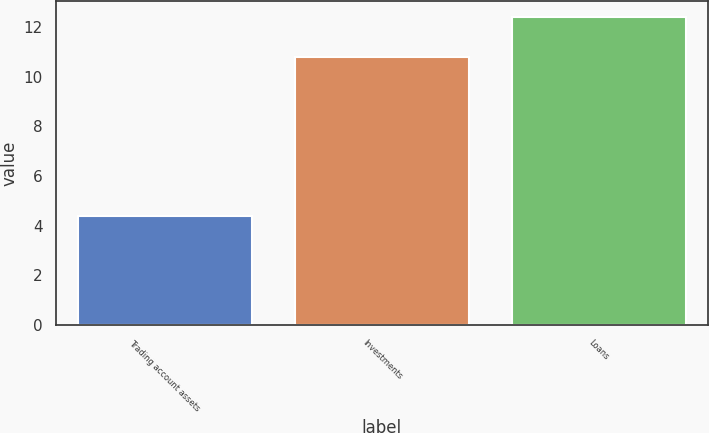Convert chart to OTSL. <chart><loc_0><loc_0><loc_500><loc_500><bar_chart><fcel>Trading account assets<fcel>Investments<fcel>Loans<nl><fcel>4.4<fcel>10.8<fcel>12.4<nl></chart> 